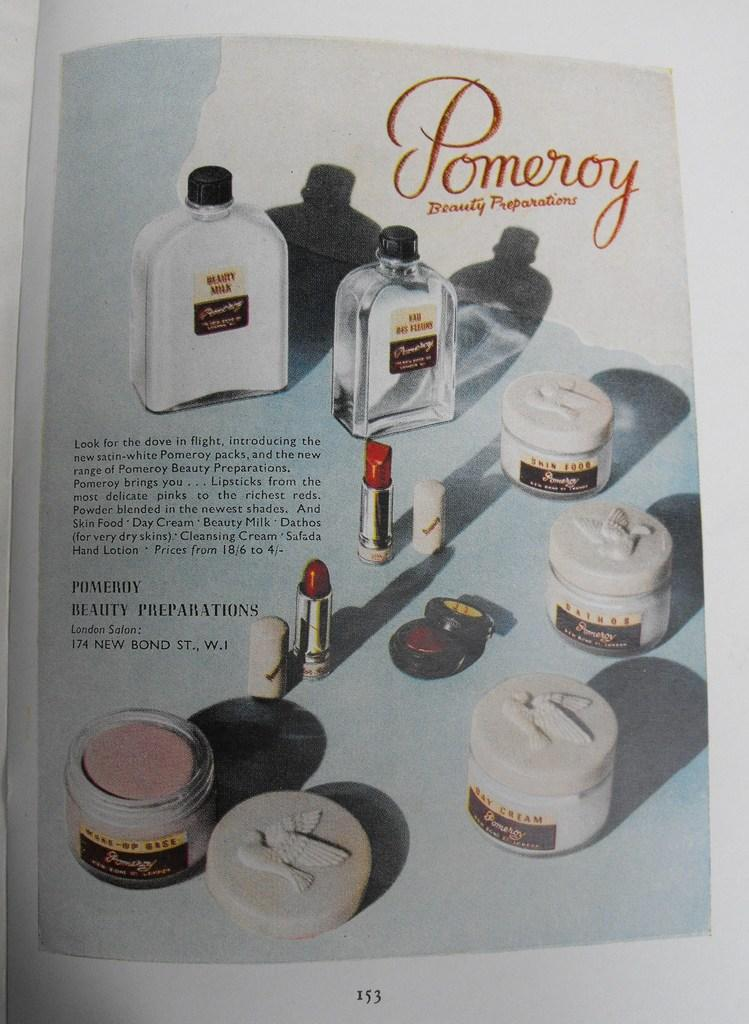<image>
Create a compact narrative representing the image presented. An advertisement in a magazine for Pomeroy beauty preparations in London. 